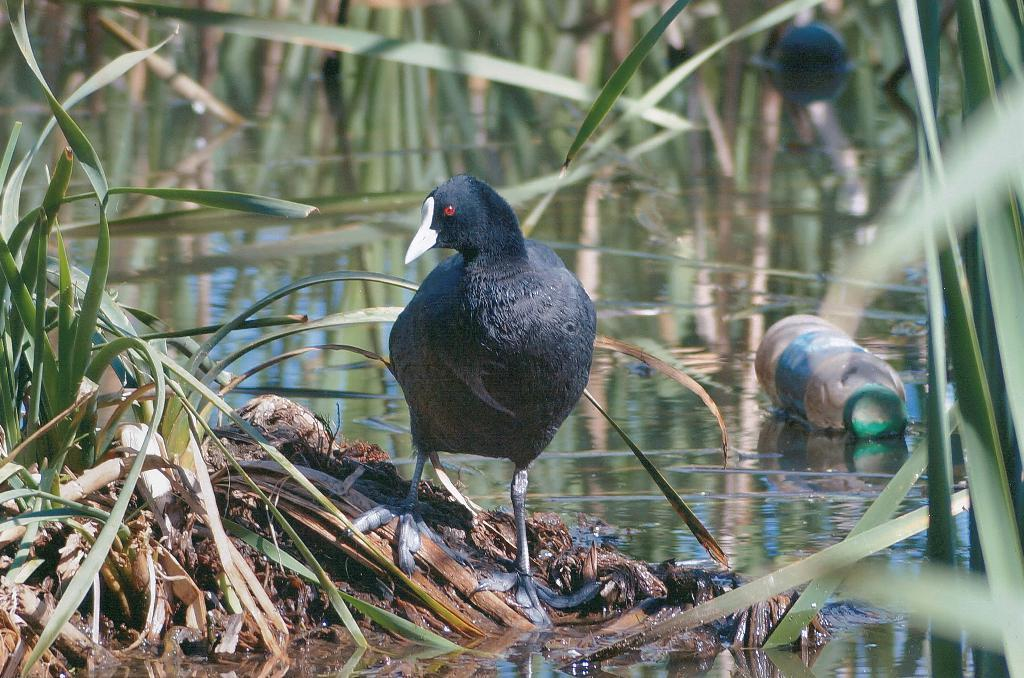What type of vegetation is present in the image? There is grass in the image. What else can be seen in the image besides grass? There is water in the image. Where is the bottle located in the image? The bottle is on the right side of the image. What kind of bird is in the middle of the image? There is a black color bird in the middle of the image. In which direction is the bird looking? The bird is looking at the left side. What type of writer can be seen in the image? There is no writer present in the image. How does the dime turn in the image? There is no dime present in the image, so it cannot turn. 